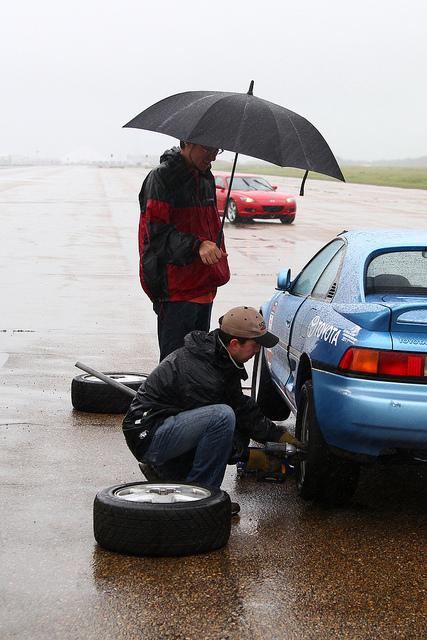Why is the man holding an umbrella?
Short answer required. Raining. What color is the vehicle?
Be succinct. Blue. What part of the car is being repaired?
Write a very short answer. Tire. 